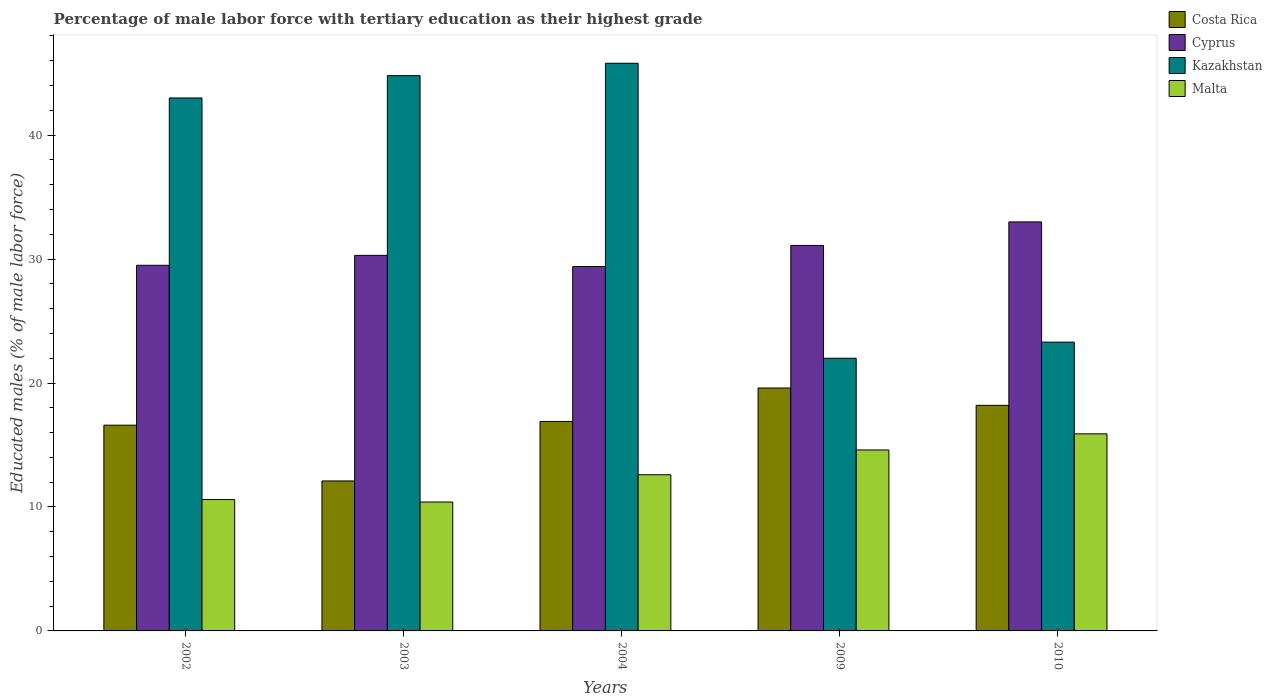Are the number of bars per tick equal to the number of legend labels?
Provide a short and direct response. Yes. Are the number of bars on each tick of the X-axis equal?
Keep it short and to the point. Yes. How many bars are there on the 3rd tick from the right?
Make the answer very short. 4. What is the label of the 4th group of bars from the left?
Offer a very short reply. 2009. In how many cases, is the number of bars for a given year not equal to the number of legend labels?
Provide a short and direct response. 0. What is the percentage of male labor force with tertiary education in Cyprus in 2004?
Offer a very short reply. 29.4. Across all years, what is the maximum percentage of male labor force with tertiary education in Malta?
Provide a succinct answer. 15.9. Across all years, what is the minimum percentage of male labor force with tertiary education in Cyprus?
Offer a very short reply. 29.4. What is the total percentage of male labor force with tertiary education in Costa Rica in the graph?
Give a very brief answer. 83.4. What is the average percentage of male labor force with tertiary education in Kazakhstan per year?
Make the answer very short. 35.78. In the year 2009, what is the difference between the percentage of male labor force with tertiary education in Kazakhstan and percentage of male labor force with tertiary education in Costa Rica?
Your answer should be compact. 2.4. What is the ratio of the percentage of male labor force with tertiary education in Kazakhstan in 2002 to that in 2004?
Give a very brief answer. 0.94. Is the percentage of male labor force with tertiary education in Cyprus in 2004 less than that in 2009?
Keep it short and to the point. Yes. What is the difference between the highest and the second highest percentage of male labor force with tertiary education in Costa Rica?
Offer a terse response. 1.4. What is the difference between the highest and the lowest percentage of male labor force with tertiary education in Cyprus?
Your answer should be very brief. 3.6. Is the sum of the percentage of male labor force with tertiary education in Malta in 2002 and 2009 greater than the maximum percentage of male labor force with tertiary education in Costa Rica across all years?
Offer a terse response. Yes. What does the 3rd bar from the left in 2004 represents?
Make the answer very short. Kazakhstan. What does the 1st bar from the right in 2002 represents?
Provide a succinct answer. Malta. Are all the bars in the graph horizontal?
Your answer should be compact. No. What is the difference between two consecutive major ticks on the Y-axis?
Your response must be concise. 10. Where does the legend appear in the graph?
Ensure brevity in your answer.  Top right. How many legend labels are there?
Your answer should be compact. 4. What is the title of the graph?
Provide a short and direct response. Percentage of male labor force with tertiary education as their highest grade. What is the label or title of the Y-axis?
Your response must be concise. Educated males (% of male labor force). What is the Educated males (% of male labor force) in Costa Rica in 2002?
Give a very brief answer. 16.6. What is the Educated males (% of male labor force) of Cyprus in 2002?
Provide a short and direct response. 29.5. What is the Educated males (% of male labor force) in Malta in 2002?
Your response must be concise. 10.6. What is the Educated males (% of male labor force) of Costa Rica in 2003?
Ensure brevity in your answer.  12.1. What is the Educated males (% of male labor force) of Cyprus in 2003?
Give a very brief answer. 30.3. What is the Educated males (% of male labor force) in Kazakhstan in 2003?
Your answer should be compact. 44.8. What is the Educated males (% of male labor force) of Malta in 2003?
Offer a very short reply. 10.4. What is the Educated males (% of male labor force) of Costa Rica in 2004?
Ensure brevity in your answer.  16.9. What is the Educated males (% of male labor force) of Cyprus in 2004?
Offer a terse response. 29.4. What is the Educated males (% of male labor force) of Kazakhstan in 2004?
Make the answer very short. 45.8. What is the Educated males (% of male labor force) in Malta in 2004?
Offer a very short reply. 12.6. What is the Educated males (% of male labor force) of Costa Rica in 2009?
Give a very brief answer. 19.6. What is the Educated males (% of male labor force) of Cyprus in 2009?
Provide a succinct answer. 31.1. What is the Educated males (% of male labor force) of Kazakhstan in 2009?
Your answer should be compact. 22. What is the Educated males (% of male labor force) of Malta in 2009?
Ensure brevity in your answer.  14.6. What is the Educated males (% of male labor force) of Costa Rica in 2010?
Your answer should be compact. 18.2. What is the Educated males (% of male labor force) in Kazakhstan in 2010?
Provide a short and direct response. 23.3. What is the Educated males (% of male labor force) of Malta in 2010?
Keep it short and to the point. 15.9. Across all years, what is the maximum Educated males (% of male labor force) of Costa Rica?
Offer a terse response. 19.6. Across all years, what is the maximum Educated males (% of male labor force) of Kazakhstan?
Offer a very short reply. 45.8. Across all years, what is the maximum Educated males (% of male labor force) of Malta?
Provide a succinct answer. 15.9. Across all years, what is the minimum Educated males (% of male labor force) of Costa Rica?
Give a very brief answer. 12.1. Across all years, what is the minimum Educated males (% of male labor force) in Cyprus?
Make the answer very short. 29.4. Across all years, what is the minimum Educated males (% of male labor force) of Kazakhstan?
Give a very brief answer. 22. Across all years, what is the minimum Educated males (% of male labor force) in Malta?
Ensure brevity in your answer.  10.4. What is the total Educated males (% of male labor force) in Costa Rica in the graph?
Provide a short and direct response. 83.4. What is the total Educated males (% of male labor force) of Cyprus in the graph?
Your answer should be very brief. 153.3. What is the total Educated males (% of male labor force) of Kazakhstan in the graph?
Offer a terse response. 178.9. What is the total Educated males (% of male labor force) in Malta in the graph?
Your answer should be compact. 64.1. What is the difference between the Educated males (% of male labor force) of Costa Rica in 2002 and that in 2003?
Make the answer very short. 4.5. What is the difference between the Educated males (% of male labor force) in Cyprus in 2002 and that in 2003?
Give a very brief answer. -0.8. What is the difference between the Educated males (% of male labor force) in Costa Rica in 2002 and that in 2004?
Provide a short and direct response. -0.3. What is the difference between the Educated males (% of male labor force) in Cyprus in 2002 and that in 2004?
Keep it short and to the point. 0.1. What is the difference between the Educated males (% of male labor force) of Cyprus in 2002 and that in 2009?
Your response must be concise. -1.6. What is the difference between the Educated males (% of male labor force) in Kazakhstan in 2002 and that in 2009?
Provide a short and direct response. 21. What is the difference between the Educated males (% of male labor force) of Malta in 2002 and that in 2009?
Give a very brief answer. -4. What is the difference between the Educated males (% of male labor force) in Costa Rica in 2002 and that in 2010?
Keep it short and to the point. -1.6. What is the difference between the Educated males (% of male labor force) in Malta in 2002 and that in 2010?
Your answer should be compact. -5.3. What is the difference between the Educated males (% of male labor force) in Costa Rica in 2003 and that in 2009?
Your answer should be compact. -7.5. What is the difference between the Educated males (% of male labor force) of Kazakhstan in 2003 and that in 2009?
Provide a succinct answer. 22.8. What is the difference between the Educated males (% of male labor force) in Costa Rica in 2003 and that in 2010?
Ensure brevity in your answer.  -6.1. What is the difference between the Educated males (% of male labor force) in Cyprus in 2003 and that in 2010?
Make the answer very short. -2.7. What is the difference between the Educated males (% of male labor force) in Kazakhstan in 2003 and that in 2010?
Keep it short and to the point. 21.5. What is the difference between the Educated males (% of male labor force) in Kazakhstan in 2004 and that in 2009?
Provide a succinct answer. 23.8. What is the difference between the Educated males (% of male labor force) of Costa Rica in 2004 and that in 2010?
Offer a terse response. -1.3. What is the difference between the Educated males (% of male labor force) in Cyprus in 2004 and that in 2010?
Make the answer very short. -3.6. What is the difference between the Educated males (% of male labor force) of Malta in 2004 and that in 2010?
Provide a short and direct response. -3.3. What is the difference between the Educated males (% of male labor force) of Malta in 2009 and that in 2010?
Give a very brief answer. -1.3. What is the difference between the Educated males (% of male labor force) in Costa Rica in 2002 and the Educated males (% of male labor force) in Cyprus in 2003?
Provide a short and direct response. -13.7. What is the difference between the Educated males (% of male labor force) of Costa Rica in 2002 and the Educated males (% of male labor force) of Kazakhstan in 2003?
Your response must be concise. -28.2. What is the difference between the Educated males (% of male labor force) of Costa Rica in 2002 and the Educated males (% of male labor force) of Malta in 2003?
Offer a very short reply. 6.2. What is the difference between the Educated males (% of male labor force) in Cyprus in 2002 and the Educated males (% of male labor force) in Kazakhstan in 2003?
Provide a short and direct response. -15.3. What is the difference between the Educated males (% of male labor force) in Kazakhstan in 2002 and the Educated males (% of male labor force) in Malta in 2003?
Keep it short and to the point. 32.6. What is the difference between the Educated males (% of male labor force) in Costa Rica in 2002 and the Educated males (% of male labor force) in Kazakhstan in 2004?
Your answer should be very brief. -29.2. What is the difference between the Educated males (% of male labor force) in Cyprus in 2002 and the Educated males (% of male labor force) in Kazakhstan in 2004?
Offer a terse response. -16.3. What is the difference between the Educated males (% of male labor force) of Cyprus in 2002 and the Educated males (% of male labor force) of Malta in 2004?
Keep it short and to the point. 16.9. What is the difference between the Educated males (% of male labor force) of Kazakhstan in 2002 and the Educated males (% of male labor force) of Malta in 2004?
Your response must be concise. 30.4. What is the difference between the Educated males (% of male labor force) of Costa Rica in 2002 and the Educated males (% of male labor force) of Malta in 2009?
Your answer should be very brief. 2. What is the difference between the Educated males (% of male labor force) in Cyprus in 2002 and the Educated males (% of male labor force) in Malta in 2009?
Provide a succinct answer. 14.9. What is the difference between the Educated males (% of male labor force) of Kazakhstan in 2002 and the Educated males (% of male labor force) of Malta in 2009?
Your answer should be compact. 28.4. What is the difference between the Educated males (% of male labor force) of Costa Rica in 2002 and the Educated males (% of male labor force) of Cyprus in 2010?
Make the answer very short. -16.4. What is the difference between the Educated males (% of male labor force) in Costa Rica in 2002 and the Educated males (% of male labor force) in Malta in 2010?
Keep it short and to the point. 0.7. What is the difference between the Educated males (% of male labor force) of Cyprus in 2002 and the Educated males (% of male labor force) of Kazakhstan in 2010?
Provide a short and direct response. 6.2. What is the difference between the Educated males (% of male labor force) in Kazakhstan in 2002 and the Educated males (% of male labor force) in Malta in 2010?
Your answer should be compact. 27.1. What is the difference between the Educated males (% of male labor force) of Costa Rica in 2003 and the Educated males (% of male labor force) of Cyprus in 2004?
Provide a succinct answer. -17.3. What is the difference between the Educated males (% of male labor force) of Costa Rica in 2003 and the Educated males (% of male labor force) of Kazakhstan in 2004?
Give a very brief answer. -33.7. What is the difference between the Educated males (% of male labor force) of Costa Rica in 2003 and the Educated males (% of male labor force) of Malta in 2004?
Keep it short and to the point. -0.5. What is the difference between the Educated males (% of male labor force) in Cyprus in 2003 and the Educated males (% of male labor force) in Kazakhstan in 2004?
Make the answer very short. -15.5. What is the difference between the Educated males (% of male labor force) of Cyprus in 2003 and the Educated males (% of male labor force) of Malta in 2004?
Provide a short and direct response. 17.7. What is the difference between the Educated males (% of male labor force) of Kazakhstan in 2003 and the Educated males (% of male labor force) of Malta in 2004?
Offer a very short reply. 32.2. What is the difference between the Educated males (% of male labor force) in Costa Rica in 2003 and the Educated males (% of male labor force) in Cyprus in 2009?
Your answer should be compact. -19. What is the difference between the Educated males (% of male labor force) in Costa Rica in 2003 and the Educated males (% of male labor force) in Malta in 2009?
Your response must be concise. -2.5. What is the difference between the Educated males (% of male labor force) in Cyprus in 2003 and the Educated males (% of male labor force) in Kazakhstan in 2009?
Provide a succinct answer. 8.3. What is the difference between the Educated males (% of male labor force) of Kazakhstan in 2003 and the Educated males (% of male labor force) of Malta in 2009?
Give a very brief answer. 30.2. What is the difference between the Educated males (% of male labor force) of Costa Rica in 2003 and the Educated males (% of male labor force) of Cyprus in 2010?
Ensure brevity in your answer.  -20.9. What is the difference between the Educated males (% of male labor force) of Costa Rica in 2003 and the Educated males (% of male labor force) of Malta in 2010?
Ensure brevity in your answer.  -3.8. What is the difference between the Educated males (% of male labor force) in Kazakhstan in 2003 and the Educated males (% of male labor force) in Malta in 2010?
Keep it short and to the point. 28.9. What is the difference between the Educated males (% of male labor force) in Cyprus in 2004 and the Educated males (% of male labor force) in Kazakhstan in 2009?
Provide a succinct answer. 7.4. What is the difference between the Educated males (% of male labor force) in Kazakhstan in 2004 and the Educated males (% of male labor force) in Malta in 2009?
Keep it short and to the point. 31.2. What is the difference between the Educated males (% of male labor force) of Costa Rica in 2004 and the Educated males (% of male labor force) of Cyprus in 2010?
Ensure brevity in your answer.  -16.1. What is the difference between the Educated males (% of male labor force) in Costa Rica in 2004 and the Educated males (% of male labor force) in Kazakhstan in 2010?
Keep it short and to the point. -6.4. What is the difference between the Educated males (% of male labor force) in Cyprus in 2004 and the Educated males (% of male labor force) in Kazakhstan in 2010?
Provide a short and direct response. 6.1. What is the difference between the Educated males (% of male labor force) in Cyprus in 2004 and the Educated males (% of male labor force) in Malta in 2010?
Keep it short and to the point. 13.5. What is the difference between the Educated males (% of male labor force) in Kazakhstan in 2004 and the Educated males (% of male labor force) in Malta in 2010?
Provide a short and direct response. 29.9. What is the difference between the Educated males (% of male labor force) of Cyprus in 2009 and the Educated males (% of male labor force) of Kazakhstan in 2010?
Your answer should be very brief. 7.8. What is the difference between the Educated males (% of male labor force) in Kazakhstan in 2009 and the Educated males (% of male labor force) in Malta in 2010?
Give a very brief answer. 6.1. What is the average Educated males (% of male labor force) of Costa Rica per year?
Keep it short and to the point. 16.68. What is the average Educated males (% of male labor force) in Cyprus per year?
Offer a very short reply. 30.66. What is the average Educated males (% of male labor force) of Kazakhstan per year?
Keep it short and to the point. 35.78. What is the average Educated males (% of male labor force) in Malta per year?
Provide a succinct answer. 12.82. In the year 2002, what is the difference between the Educated males (% of male labor force) in Costa Rica and Educated males (% of male labor force) in Kazakhstan?
Your answer should be compact. -26.4. In the year 2002, what is the difference between the Educated males (% of male labor force) in Costa Rica and Educated males (% of male labor force) in Malta?
Your answer should be very brief. 6. In the year 2002, what is the difference between the Educated males (% of male labor force) of Kazakhstan and Educated males (% of male labor force) of Malta?
Make the answer very short. 32.4. In the year 2003, what is the difference between the Educated males (% of male labor force) in Costa Rica and Educated males (% of male labor force) in Cyprus?
Give a very brief answer. -18.2. In the year 2003, what is the difference between the Educated males (% of male labor force) of Costa Rica and Educated males (% of male labor force) of Kazakhstan?
Provide a succinct answer. -32.7. In the year 2003, what is the difference between the Educated males (% of male labor force) in Costa Rica and Educated males (% of male labor force) in Malta?
Keep it short and to the point. 1.7. In the year 2003, what is the difference between the Educated males (% of male labor force) of Cyprus and Educated males (% of male labor force) of Malta?
Make the answer very short. 19.9. In the year 2003, what is the difference between the Educated males (% of male labor force) in Kazakhstan and Educated males (% of male labor force) in Malta?
Offer a very short reply. 34.4. In the year 2004, what is the difference between the Educated males (% of male labor force) in Costa Rica and Educated males (% of male labor force) in Cyprus?
Offer a very short reply. -12.5. In the year 2004, what is the difference between the Educated males (% of male labor force) of Costa Rica and Educated males (% of male labor force) of Kazakhstan?
Your response must be concise. -28.9. In the year 2004, what is the difference between the Educated males (% of male labor force) in Costa Rica and Educated males (% of male labor force) in Malta?
Provide a succinct answer. 4.3. In the year 2004, what is the difference between the Educated males (% of male labor force) in Cyprus and Educated males (% of male labor force) in Kazakhstan?
Offer a terse response. -16.4. In the year 2004, what is the difference between the Educated males (% of male labor force) in Cyprus and Educated males (% of male labor force) in Malta?
Give a very brief answer. 16.8. In the year 2004, what is the difference between the Educated males (% of male labor force) of Kazakhstan and Educated males (% of male labor force) of Malta?
Ensure brevity in your answer.  33.2. In the year 2009, what is the difference between the Educated males (% of male labor force) in Costa Rica and Educated males (% of male labor force) in Kazakhstan?
Offer a terse response. -2.4. In the year 2009, what is the difference between the Educated males (% of male labor force) of Costa Rica and Educated males (% of male labor force) of Malta?
Make the answer very short. 5. In the year 2009, what is the difference between the Educated males (% of male labor force) of Cyprus and Educated males (% of male labor force) of Kazakhstan?
Your answer should be very brief. 9.1. In the year 2009, what is the difference between the Educated males (% of male labor force) of Kazakhstan and Educated males (% of male labor force) of Malta?
Provide a short and direct response. 7.4. In the year 2010, what is the difference between the Educated males (% of male labor force) of Costa Rica and Educated males (% of male labor force) of Cyprus?
Provide a short and direct response. -14.8. In the year 2010, what is the difference between the Educated males (% of male labor force) in Costa Rica and Educated males (% of male labor force) in Kazakhstan?
Your answer should be compact. -5.1. In the year 2010, what is the difference between the Educated males (% of male labor force) of Cyprus and Educated males (% of male labor force) of Malta?
Your answer should be very brief. 17.1. In the year 2010, what is the difference between the Educated males (% of male labor force) of Kazakhstan and Educated males (% of male labor force) of Malta?
Keep it short and to the point. 7.4. What is the ratio of the Educated males (% of male labor force) of Costa Rica in 2002 to that in 2003?
Offer a terse response. 1.37. What is the ratio of the Educated males (% of male labor force) of Cyprus in 2002 to that in 2003?
Your answer should be compact. 0.97. What is the ratio of the Educated males (% of male labor force) of Kazakhstan in 2002 to that in 2003?
Keep it short and to the point. 0.96. What is the ratio of the Educated males (% of male labor force) in Malta in 2002 to that in 2003?
Keep it short and to the point. 1.02. What is the ratio of the Educated males (% of male labor force) in Costa Rica in 2002 to that in 2004?
Keep it short and to the point. 0.98. What is the ratio of the Educated males (% of male labor force) in Kazakhstan in 2002 to that in 2004?
Make the answer very short. 0.94. What is the ratio of the Educated males (% of male labor force) of Malta in 2002 to that in 2004?
Ensure brevity in your answer.  0.84. What is the ratio of the Educated males (% of male labor force) of Costa Rica in 2002 to that in 2009?
Provide a succinct answer. 0.85. What is the ratio of the Educated males (% of male labor force) of Cyprus in 2002 to that in 2009?
Give a very brief answer. 0.95. What is the ratio of the Educated males (% of male labor force) of Kazakhstan in 2002 to that in 2009?
Ensure brevity in your answer.  1.95. What is the ratio of the Educated males (% of male labor force) in Malta in 2002 to that in 2009?
Make the answer very short. 0.73. What is the ratio of the Educated males (% of male labor force) of Costa Rica in 2002 to that in 2010?
Give a very brief answer. 0.91. What is the ratio of the Educated males (% of male labor force) of Cyprus in 2002 to that in 2010?
Your response must be concise. 0.89. What is the ratio of the Educated males (% of male labor force) of Kazakhstan in 2002 to that in 2010?
Keep it short and to the point. 1.85. What is the ratio of the Educated males (% of male labor force) in Malta in 2002 to that in 2010?
Provide a short and direct response. 0.67. What is the ratio of the Educated males (% of male labor force) in Costa Rica in 2003 to that in 2004?
Your answer should be very brief. 0.72. What is the ratio of the Educated males (% of male labor force) in Cyprus in 2003 to that in 2004?
Your answer should be very brief. 1.03. What is the ratio of the Educated males (% of male labor force) in Kazakhstan in 2003 to that in 2004?
Provide a succinct answer. 0.98. What is the ratio of the Educated males (% of male labor force) of Malta in 2003 to that in 2004?
Offer a terse response. 0.83. What is the ratio of the Educated males (% of male labor force) of Costa Rica in 2003 to that in 2009?
Your answer should be compact. 0.62. What is the ratio of the Educated males (% of male labor force) in Cyprus in 2003 to that in 2009?
Your answer should be very brief. 0.97. What is the ratio of the Educated males (% of male labor force) of Kazakhstan in 2003 to that in 2009?
Provide a succinct answer. 2.04. What is the ratio of the Educated males (% of male labor force) in Malta in 2003 to that in 2009?
Ensure brevity in your answer.  0.71. What is the ratio of the Educated males (% of male labor force) in Costa Rica in 2003 to that in 2010?
Provide a short and direct response. 0.66. What is the ratio of the Educated males (% of male labor force) of Cyprus in 2003 to that in 2010?
Your response must be concise. 0.92. What is the ratio of the Educated males (% of male labor force) in Kazakhstan in 2003 to that in 2010?
Your response must be concise. 1.92. What is the ratio of the Educated males (% of male labor force) of Malta in 2003 to that in 2010?
Give a very brief answer. 0.65. What is the ratio of the Educated males (% of male labor force) in Costa Rica in 2004 to that in 2009?
Offer a very short reply. 0.86. What is the ratio of the Educated males (% of male labor force) in Cyprus in 2004 to that in 2009?
Make the answer very short. 0.95. What is the ratio of the Educated males (% of male labor force) in Kazakhstan in 2004 to that in 2009?
Your response must be concise. 2.08. What is the ratio of the Educated males (% of male labor force) in Malta in 2004 to that in 2009?
Give a very brief answer. 0.86. What is the ratio of the Educated males (% of male labor force) of Costa Rica in 2004 to that in 2010?
Provide a succinct answer. 0.93. What is the ratio of the Educated males (% of male labor force) in Cyprus in 2004 to that in 2010?
Your response must be concise. 0.89. What is the ratio of the Educated males (% of male labor force) of Kazakhstan in 2004 to that in 2010?
Provide a short and direct response. 1.97. What is the ratio of the Educated males (% of male labor force) in Malta in 2004 to that in 2010?
Your answer should be compact. 0.79. What is the ratio of the Educated males (% of male labor force) in Costa Rica in 2009 to that in 2010?
Make the answer very short. 1.08. What is the ratio of the Educated males (% of male labor force) in Cyprus in 2009 to that in 2010?
Make the answer very short. 0.94. What is the ratio of the Educated males (% of male labor force) of Kazakhstan in 2009 to that in 2010?
Your response must be concise. 0.94. What is the ratio of the Educated males (% of male labor force) in Malta in 2009 to that in 2010?
Your answer should be compact. 0.92. What is the difference between the highest and the second highest Educated males (% of male labor force) of Costa Rica?
Give a very brief answer. 1.4. What is the difference between the highest and the second highest Educated males (% of male labor force) in Kazakhstan?
Your response must be concise. 1. What is the difference between the highest and the second highest Educated males (% of male labor force) of Malta?
Ensure brevity in your answer.  1.3. What is the difference between the highest and the lowest Educated males (% of male labor force) of Costa Rica?
Your response must be concise. 7.5. What is the difference between the highest and the lowest Educated males (% of male labor force) of Cyprus?
Keep it short and to the point. 3.6. What is the difference between the highest and the lowest Educated males (% of male labor force) in Kazakhstan?
Offer a very short reply. 23.8. 